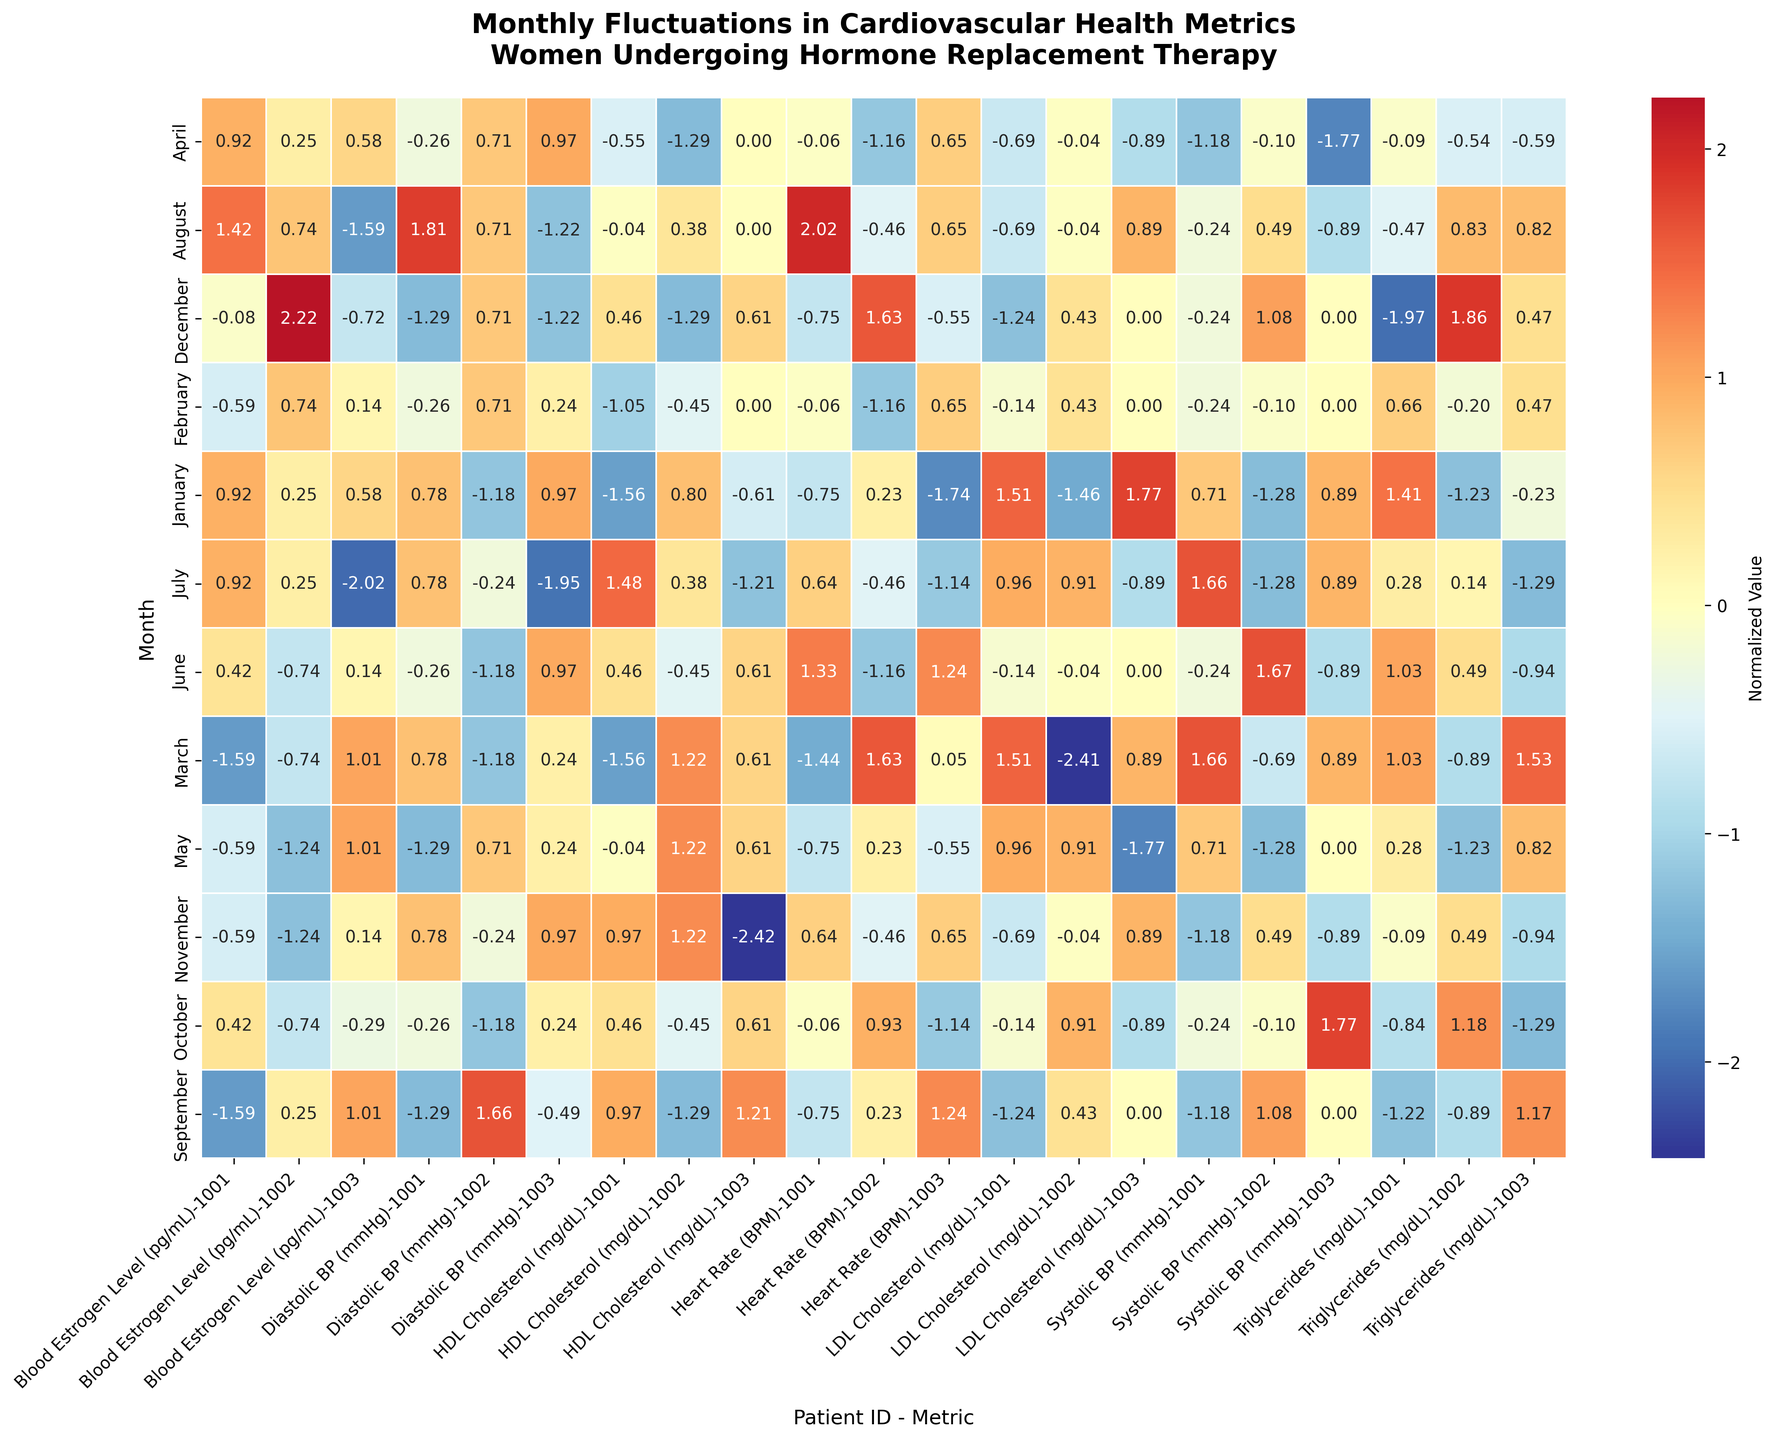What does the title of the heatmap indicate about the metric being visualized? The title "Monthly Fluctuations in Cardiovascular Health Metrics\nWomen Undergoing Hormone Replacement Therapy" suggests that the heatmap visualizes changes in various cardiovascular health metrics over each month for women undergoing hormone replacement therapy.
Answer: Changes in cardiovascular health metrics over months Which month shows the most variance across different patients for systolic blood pressure? To identify the month with the most variance in systolic blood pressure, look for the month where the heatmap cells related to systolic blood pressure vary most widely from each other in color.
Answer: June Is the heart rate more stable in January compared to July? Compare the variation in colors for the heart rate row for January and July. Less variation in the color would indicate more stability.
Answer: Yes Which metric shows the largest fluctuation for patient 1003 in August? Look at the August row and identify the metric column for patient 1003 that has a cell color most different from the baseline.
Answer: Blood Estrogen Level How does the LDL Cholesterol vary across months for patient 1002? Follow the row for LDL Cholesterol across all months and note the color shifts for patient 1002's column.
Answer: It shows moderate fluctuation For September, how do the normalized values for systolic BP for patient 1001 and patient 1002 compare? Compare the colors in the September row under the systolic BP metric for patient 1001 and patient 1002. Determine which cell has a color indicating higher or lower normalized value.
Answer: Patient 1002 > Patient 1001 Which month has the highest normalized value for HDL cholesterol for any patient? Examine the rows for HDL cholesterol and identify which month has the most extreme color variation indicating the highest normalized value.
Answer: October What is the general trend for blood estrogen levels throughout the year? Look for the color gradient within the row for blood estrogen levels across all months. The tendency of color shift indicates an uptrend or downtrend.
Answer: Moderately fluctuates How does the variation in diastolic BP for patient 1001 in December compare to November? Compare the December and November rows for diastolic BP of patient 1001 by noting the difference in colors between these months.
Answer: December has less variation Which patient shows the most consistent triglyceride levels throughout the year? Observe the row for triglyceride levels and look for the patient column with the least color variation across all months.
Answer: Patient 1002 